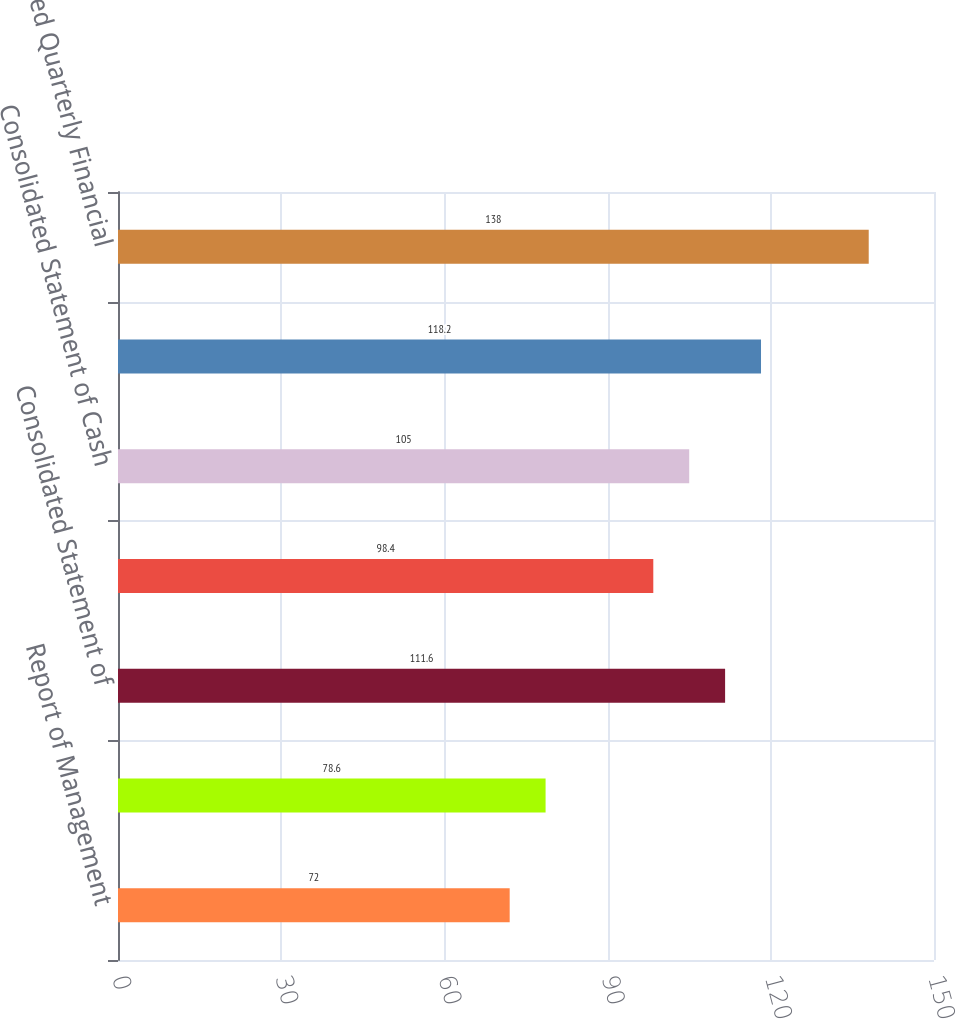Convert chart to OTSL. <chart><loc_0><loc_0><loc_500><loc_500><bar_chart><fcel>Report of Management<fcel>Reports of Independent<fcel>Consolidated Statement of<fcel>Consolidated Balance Sheet at<fcel>Consolidated Statement of Cash<fcel>Notes to Consolidated<fcel>Selected Quarterly Financial<nl><fcel>72<fcel>78.6<fcel>111.6<fcel>98.4<fcel>105<fcel>118.2<fcel>138<nl></chart> 